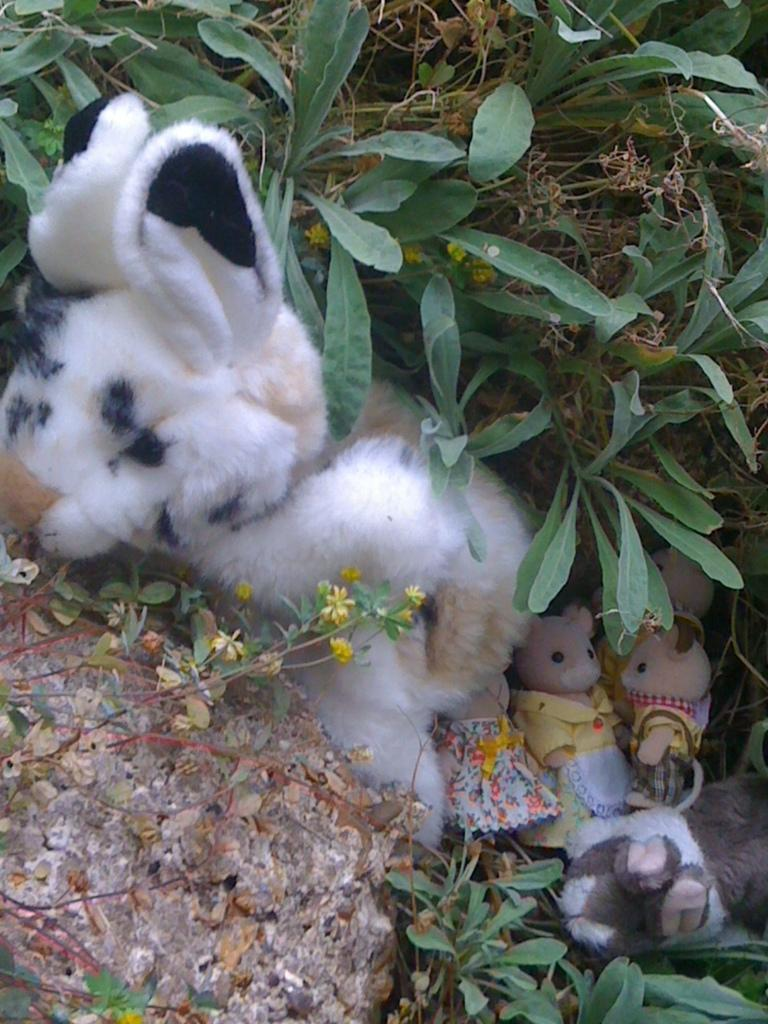What objects are on the ground in the image? There are toys on the ground in the image. What type of object can be seen in the foreground of the image? There is a stone visible in the image. What can be seen in the background of the image? There are plants in the background of the image. What song is being sung by the manager in the image? There is no manager or song present in the image. What type of chair is visible in the image? There is no chair present in the image. 